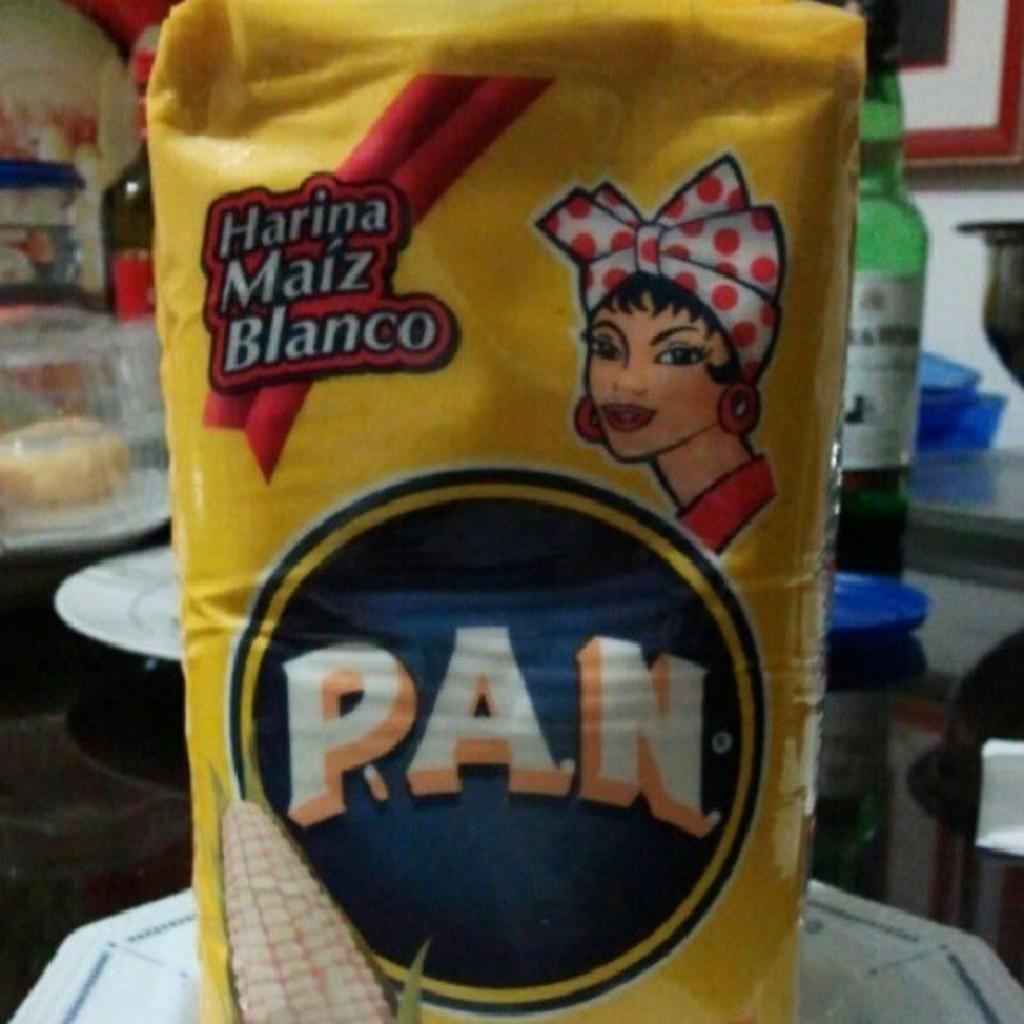What is the name of this product shown?
Provide a succinct answer. Pan. What brand is this cornmeal?
Give a very brief answer. Pan. 